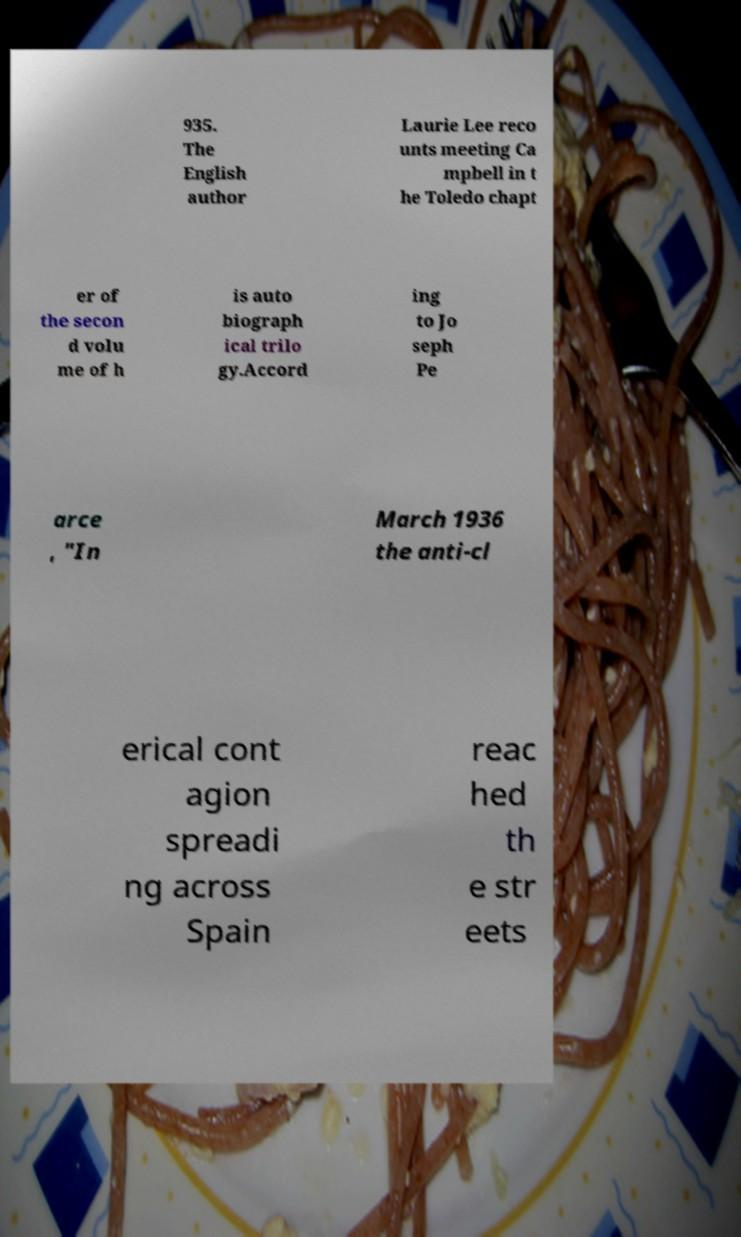There's text embedded in this image that I need extracted. Can you transcribe it verbatim? 935. The English author Laurie Lee reco unts meeting Ca mpbell in t he Toledo chapt er of the secon d volu me of h is auto biograph ical trilo gy.Accord ing to Jo seph Pe arce , "In March 1936 the anti-cl erical cont agion spreadi ng across Spain reac hed th e str eets 